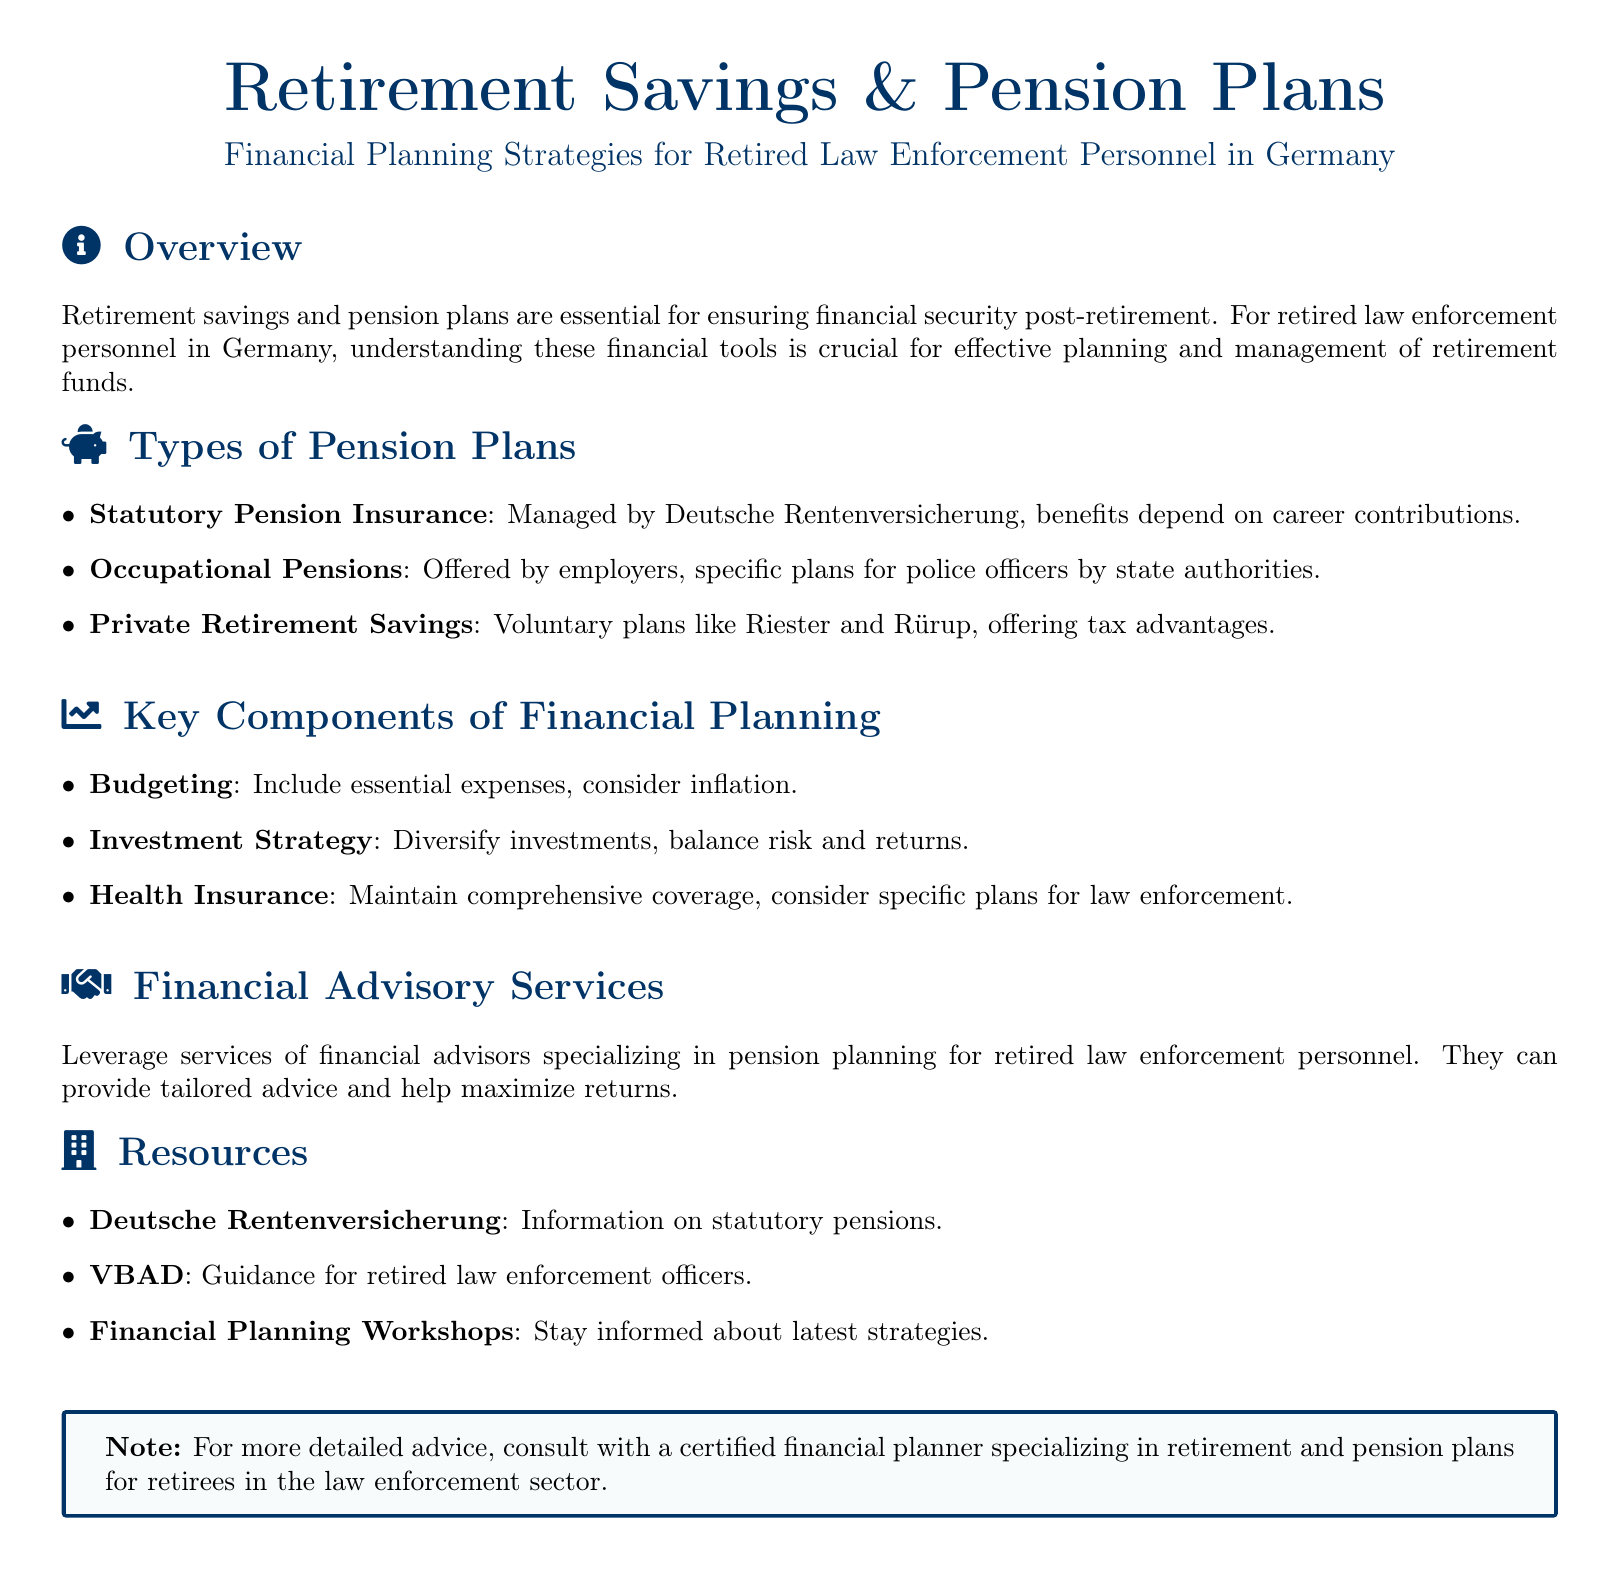What is the primary purpose of the document? The document provides information on financial planning strategies related to retirement savings and pension plans for retired law enforcement personnel in Germany.
Answer: Financial planning strategies What organization manages Statutory Pension Insurance? The document states that Statutory Pension Insurance is managed by Deutsche Rentenversicherung.
Answer: Deutsche Rentenversicherung Which type of pension plan is offered specifically by state authorities? The document mentions Occupational Pensions as being offered by employers, specifically plans for police officers by state authorities.
Answer: Occupational Pensions What should be included in budgeting for retirement? The document lists essential expenses and inflation as key considerations in budgeting for retirement.
Answer: Essential expenses, inflation What kind of financial services should retired law enforcement personnel leverage? The document advises utilizing financial advisory services specializing in pension planning.
Answer: Financial advisory services What is a tax-advantaged private retirement savings plan mentioned in the document? The document mentions Riester plans as a type of private retirement savings plan that offers tax advantages.
Answer: Riester What is a recommended resource for information on statutory pensions? The document lists Deutsche Rentenversicherung as a resource for information on statutory pensions.
Answer: Deutsche Rentenversicherung What is essential to maintain when planning for healthcare in retirement? According to the document, maintaining comprehensive health insurance coverage is essential.
Answer: Comprehensive health insurance Which workshops should retirees attend to stay informed? The document encourages participation in Financial Planning Workshops to stay updated on strategies.
Answer: Financial Planning Workshops 